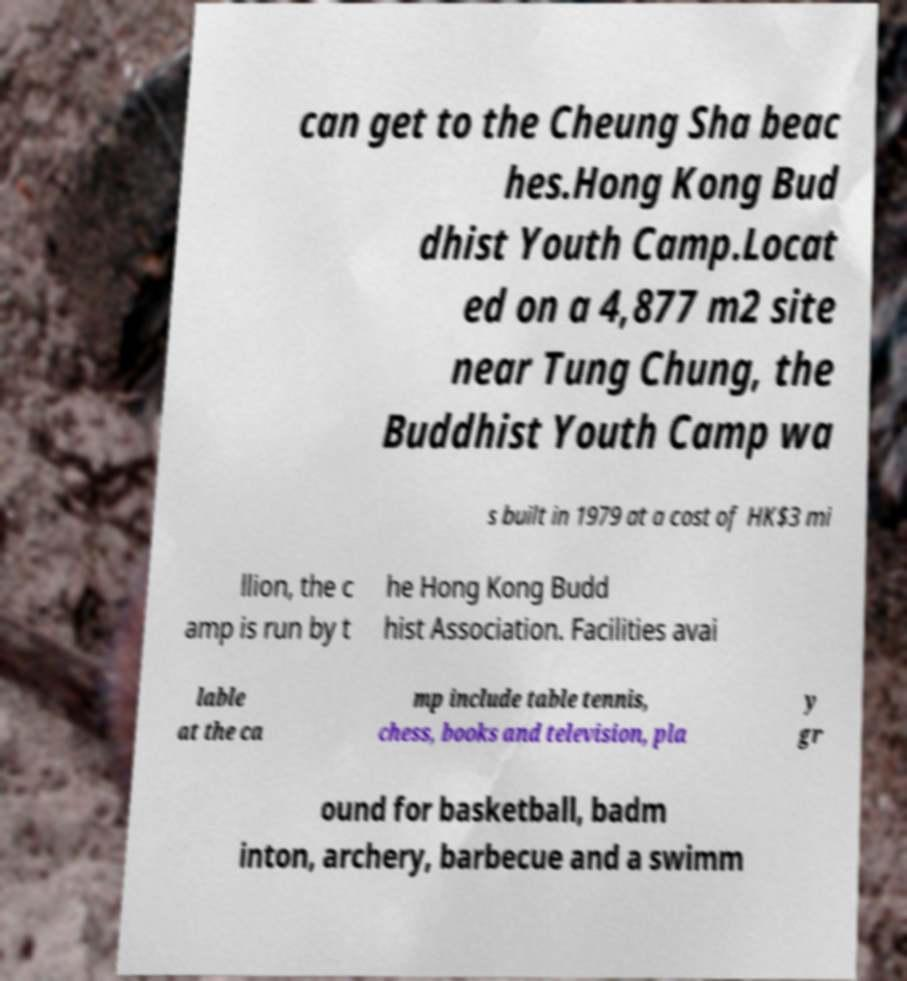What messages or text are displayed in this image? I need them in a readable, typed format. can get to the Cheung Sha beac hes.Hong Kong Bud dhist Youth Camp.Locat ed on a 4,877 m2 site near Tung Chung, the Buddhist Youth Camp wa s built in 1979 at a cost of HK$3 mi llion, the c amp is run by t he Hong Kong Budd hist Association. Facilities avai lable at the ca mp include table tennis, chess, books and television, pla y gr ound for basketball, badm inton, archery, barbecue and a swimm 